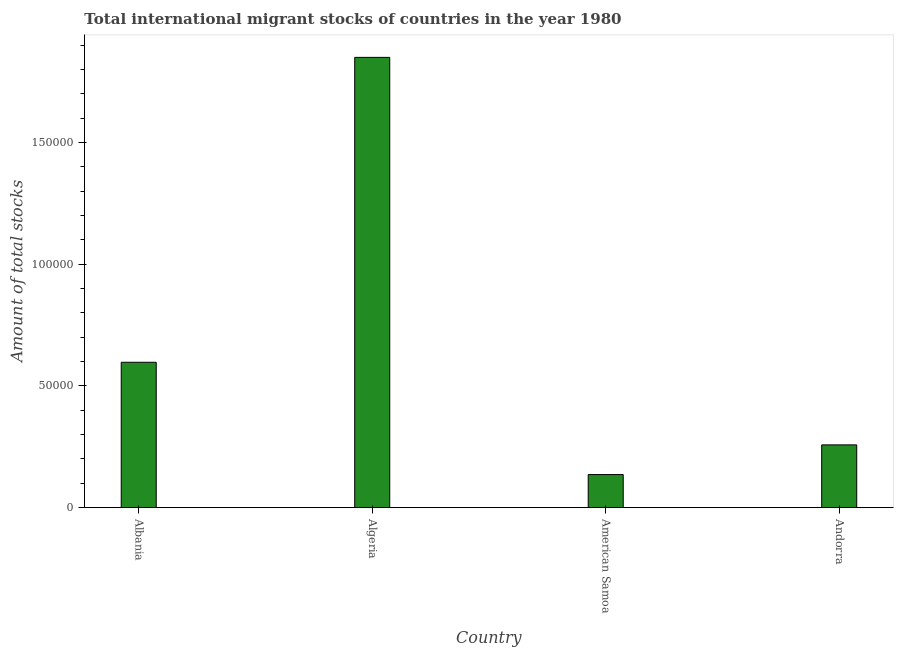What is the title of the graph?
Offer a very short reply. Total international migrant stocks of countries in the year 1980. What is the label or title of the Y-axis?
Provide a short and direct response. Amount of total stocks. What is the total number of international migrant stock in Albania?
Ensure brevity in your answer.  5.97e+04. Across all countries, what is the maximum total number of international migrant stock?
Provide a succinct answer. 1.85e+05. Across all countries, what is the minimum total number of international migrant stock?
Offer a very short reply. 1.36e+04. In which country was the total number of international migrant stock maximum?
Provide a short and direct response. Algeria. In which country was the total number of international migrant stock minimum?
Your answer should be compact. American Samoa. What is the sum of the total number of international migrant stock?
Make the answer very short. 2.84e+05. What is the difference between the total number of international migrant stock in Albania and American Samoa?
Your answer should be compact. 4.61e+04. What is the average total number of international migrant stock per country?
Your response must be concise. 7.10e+04. What is the median total number of international migrant stock?
Make the answer very short. 4.28e+04. In how many countries, is the total number of international migrant stock greater than 30000 ?
Ensure brevity in your answer.  2. What is the ratio of the total number of international migrant stock in Albania to that in Andorra?
Give a very brief answer. 2.32. Is the total number of international migrant stock in American Samoa less than that in Andorra?
Your answer should be compact. Yes. What is the difference between the highest and the second highest total number of international migrant stock?
Offer a very short reply. 1.25e+05. Is the sum of the total number of international migrant stock in Albania and Andorra greater than the maximum total number of international migrant stock across all countries?
Your answer should be compact. No. What is the difference between the highest and the lowest total number of international migrant stock?
Your answer should be compact. 1.71e+05. In how many countries, is the total number of international migrant stock greater than the average total number of international migrant stock taken over all countries?
Your answer should be compact. 1. How many bars are there?
Your answer should be compact. 4. Are all the bars in the graph horizontal?
Your response must be concise. No. Are the values on the major ticks of Y-axis written in scientific E-notation?
Provide a short and direct response. No. What is the Amount of total stocks of Albania?
Give a very brief answer. 5.97e+04. What is the Amount of total stocks in Algeria?
Offer a terse response. 1.85e+05. What is the Amount of total stocks of American Samoa?
Your answer should be compact. 1.36e+04. What is the Amount of total stocks in Andorra?
Ensure brevity in your answer.  2.58e+04. What is the difference between the Amount of total stocks in Albania and Algeria?
Provide a succinct answer. -1.25e+05. What is the difference between the Amount of total stocks in Albania and American Samoa?
Your answer should be compact. 4.61e+04. What is the difference between the Amount of total stocks in Albania and Andorra?
Ensure brevity in your answer.  3.39e+04. What is the difference between the Amount of total stocks in Algeria and American Samoa?
Give a very brief answer. 1.71e+05. What is the difference between the Amount of total stocks in Algeria and Andorra?
Give a very brief answer. 1.59e+05. What is the difference between the Amount of total stocks in American Samoa and Andorra?
Make the answer very short. -1.22e+04. What is the ratio of the Amount of total stocks in Albania to that in Algeria?
Keep it short and to the point. 0.32. What is the ratio of the Amount of total stocks in Albania to that in American Samoa?
Provide a short and direct response. 4.39. What is the ratio of the Amount of total stocks in Albania to that in Andorra?
Your answer should be very brief. 2.32. What is the ratio of the Amount of total stocks in Algeria to that in American Samoa?
Your response must be concise. 13.61. What is the ratio of the Amount of total stocks in Algeria to that in Andorra?
Your response must be concise. 7.17. What is the ratio of the Amount of total stocks in American Samoa to that in Andorra?
Your answer should be compact. 0.53. 